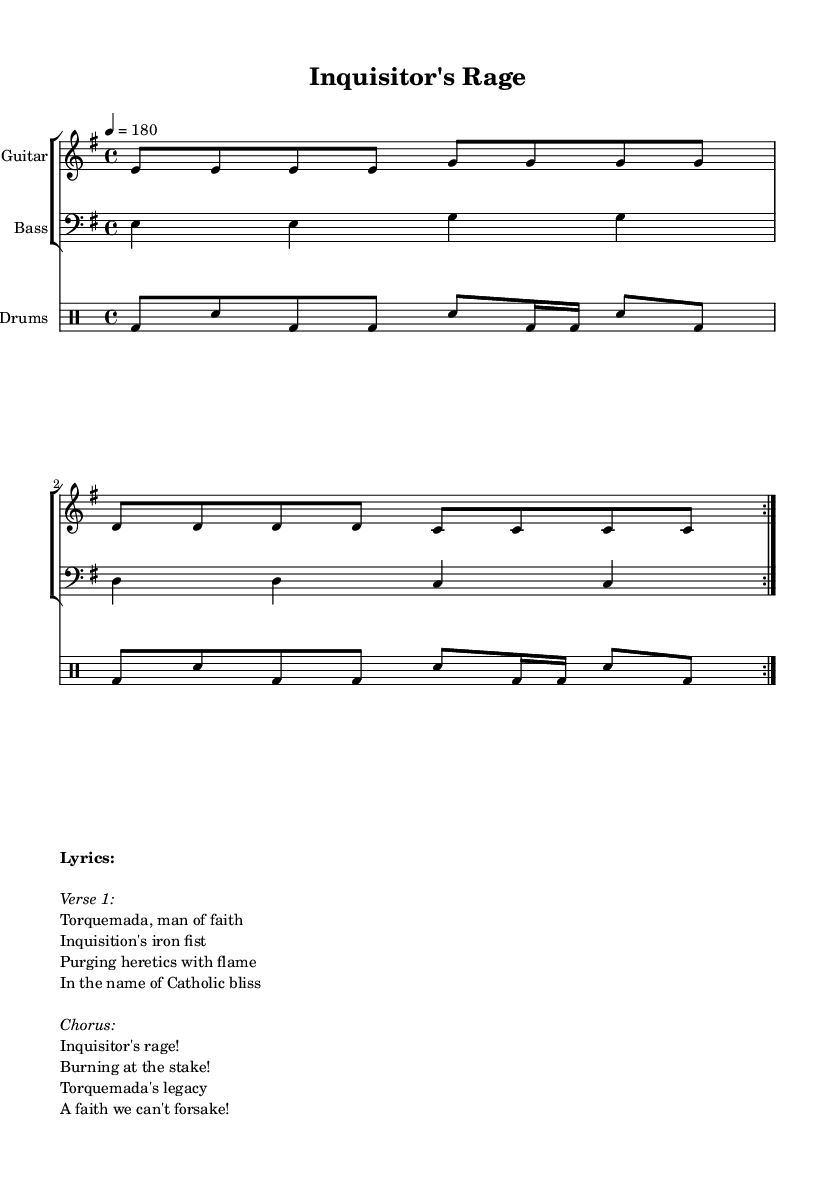What is the key signature of this music? The key signature is E minor, which includes one sharp (F#) and is indicated at the beginning of the score.
Answer: E minor What is the time signature of this music? The time signature is 4/4, which means there are four beats in each measure and the quarter note receives one beat. This is clearly marked at the beginning of the score.
Answer: 4/4 What is the tempo marking for this piece? The tempo is marked as 180 beats per minute, indicated by the "tempo 4 = 180" instruction at the start of the global music section.
Answer: 180 How many times is the guitar riff repeated? The guitar riff is repeated twice, indicated by the “\repeat volta 2” instruction before the guitar riff notation.
Answer: 2 What historical figure is referenced in the lyrics? The lyrics of the song reference Torquemada, who was the Grand Inquisitor during the Spanish Inquisition. This is explicitly mentioned in the first line of the lyrics.
Answer: Torquemada What phrase is used in the chorus of the song? The chorus includes the phrase "Inquisitor's rage!", which is presented prominently and expresses the central theme of the song.
Answer: Inquisitor's rage! What theme does this punk song address? The theme of the song addresses the controversial legacy of religious authority and the Inquisition, focusing on violence against heretics in the name of faith. This is inferred from the lyrics discussing Torquemada and the act of burning at the stake.
Answer: Religious authority 